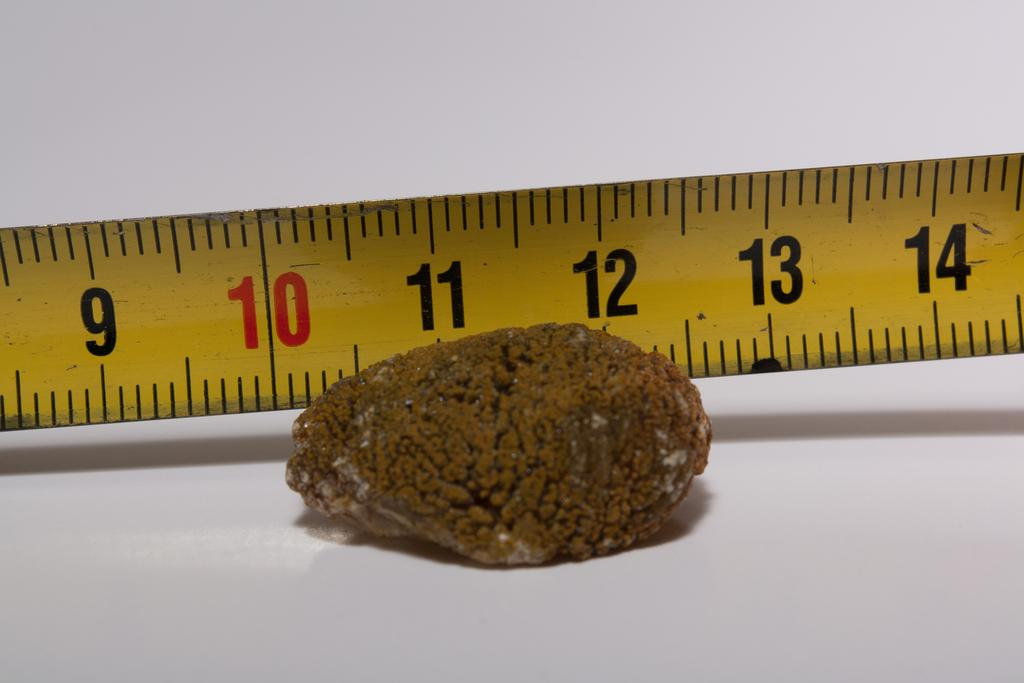<image>
Create a compact narrative representing the image presented. An brown object laying in front of a measuring tape that shows it measuring 2 inches. 